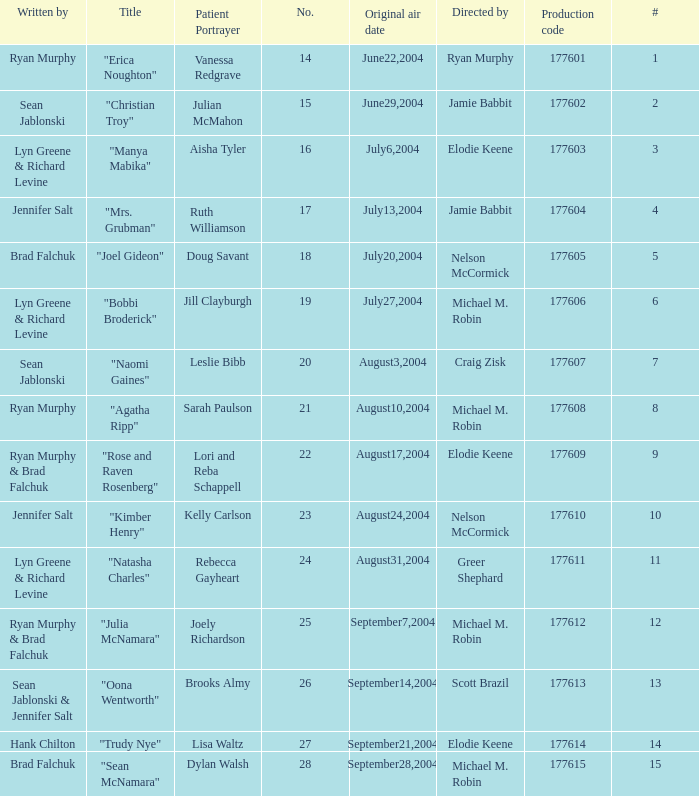Who wrote episode number 28? Brad Falchuk. 